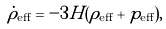Convert formula to latex. <formula><loc_0><loc_0><loc_500><loc_500>\dot { \rho } _ { \text {eff} } = - 3 H ( \rho _ { \text {eff} } + p _ { \text {eff} } ) ,</formula> 